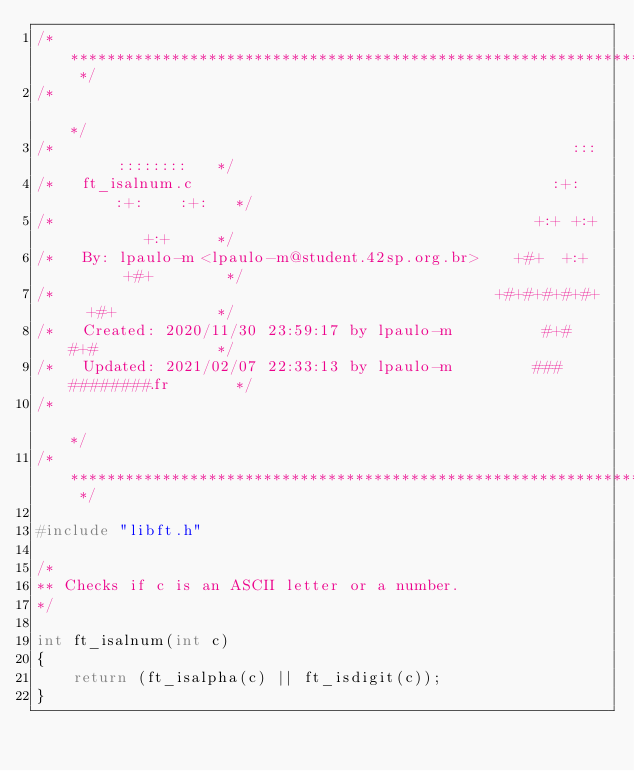<code> <loc_0><loc_0><loc_500><loc_500><_C_>/* ************************************************************************** */
/*                                                                            */
/*                                                        :::      ::::::::   */
/*   ft_isalnum.c                                       :+:      :+:    :+:   */
/*                                                    +:+ +:+         +:+     */
/*   By: lpaulo-m <lpaulo-m@student.42sp.org.br>    +#+  +:+       +#+        */
/*                                                +#+#+#+#+#+   +#+           */
/*   Created: 2020/11/30 23:59:17 by lpaulo-m          #+#    #+#             */
/*   Updated: 2021/02/07 22:33:13 by lpaulo-m         ###   ########.fr       */
/*                                                                            */
/* ************************************************************************** */

#include "libft.h"

/*
** Checks if c is an ASCII letter or a number.
*/

int	ft_isalnum(int c)
{
	return (ft_isalpha(c) || ft_isdigit(c));
}
</code> 